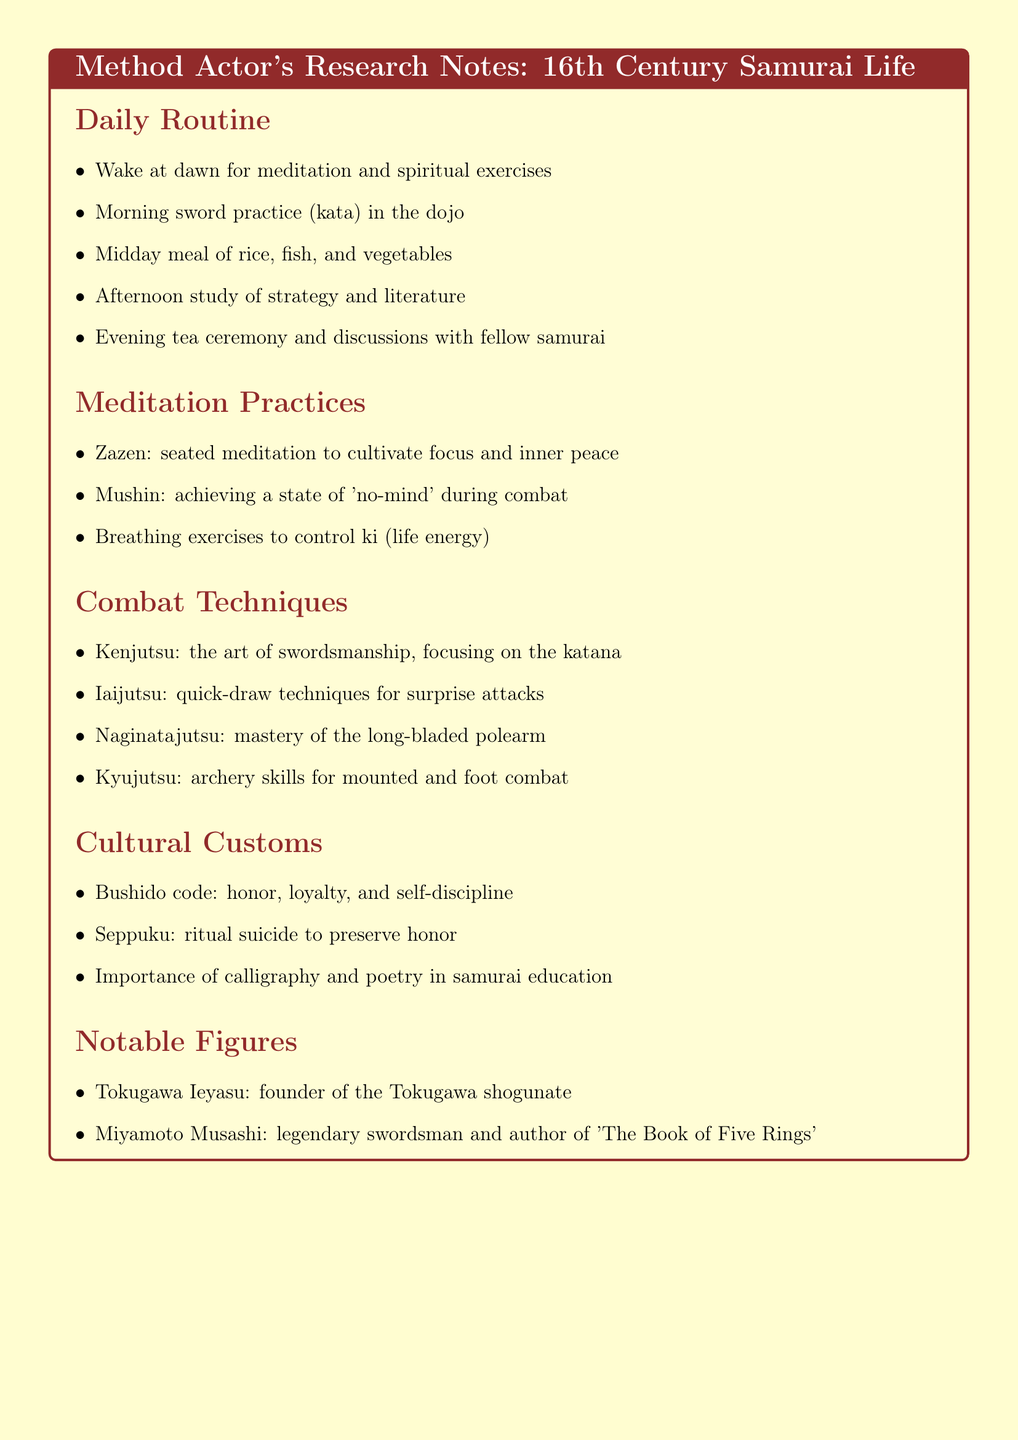What time do samurai wake up? The document states that samurai wake at dawn for meditation and spiritual exercises.
Answer: dawn What is the afternoon activity listed in the daily routine? The daily routine includes the study of strategy and literature in the afternoon.
Answer: study of strategy and literature What is Zazen? Zazen is described in the document as seated meditation to cultivate focus and inner peace.
Answer: seated meditation Which combat technique focuses on quick-draw? Iaijutsu is highlighted as the quick-draw technique for surprise attacks in the combat techniques section.
Answer: Iaijutsu What does the Bushido code emphasize? The Bushido code emphasizes honor, loyalty, and self-discipline as mentioned in the cultural customs section.
Answer: honor, loyalty, and self-discipline Who founded the Tokugawa shogunate? The document lists Tokugawa Ieyasu as the founder of the Tokugawa shogunate.
Answer: Tokugawa Ieyasu What is the significance of calligraphy in samurai education? The document notes that calligraphy is important in samurai education as part of their cultural customs.
Answer: importance of calligraphy How many combat techniques are listed? The document details four specific combat techniques.
Answer: four What is the meditation practice that achieves 'no-mind' during combat? The Mushin practice is mentioned as achieving a state of 'no-mind' during combat.
Answer: Mushin 